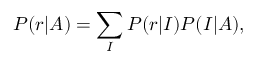<formula> <loc_0><loc_0><loc_500><loc_500>P ( r | A ) = \sum _ { I } P ( r | I ) P ( I | A ) ,</formula> 